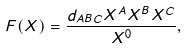Convert formula to latex. <formula><loc_0><loc_0><loc_500><loc_500>F ( X ) = \frac { d _ { A B C } X ^ { A } X ^ { B } X ^ { C } } { X ^ { 0 } } ,</formula> 